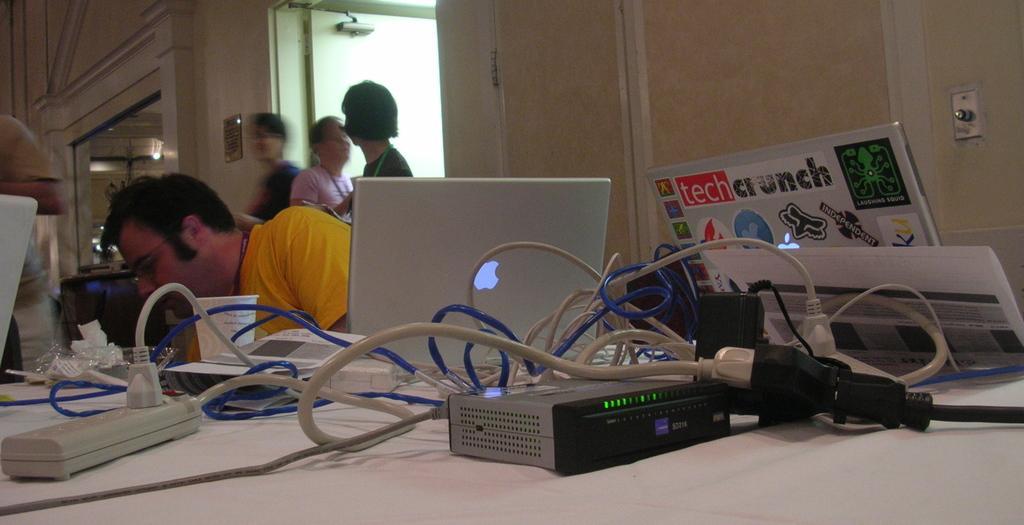In one or two sentences, can you explain what this image depicts? In the picture I can see electrical devices, wires, laptop and few more objects are placed on the table. Here I can see a person wearing yellow color T-shirt is sitting near the table. In the background, I can see a few people standing, I can see the glass windows through which I can see the lights. 